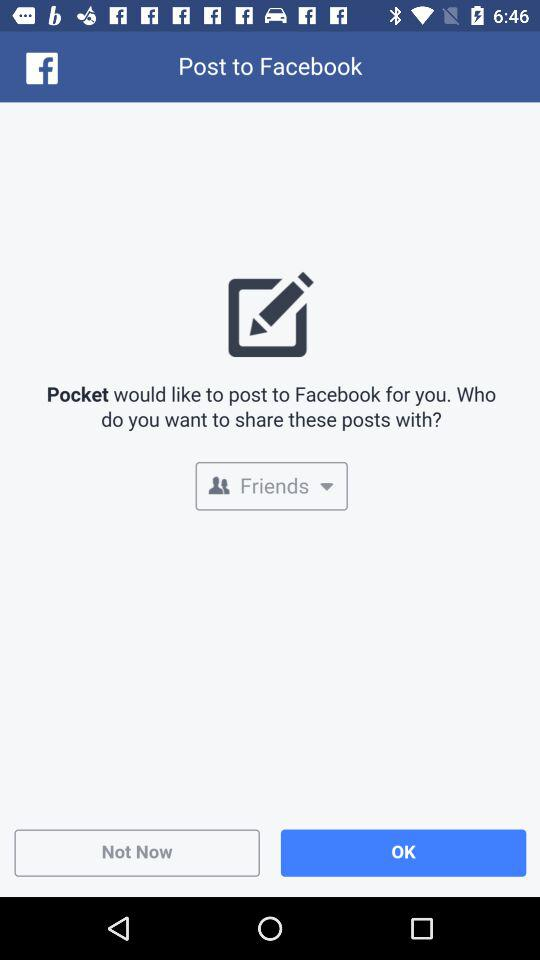Through what application can we post? You can post with "Pocket". 